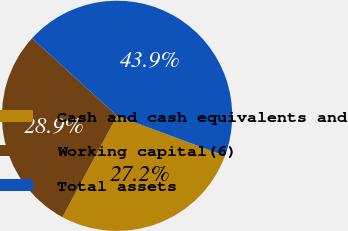Convert chart to OTSL. <chart><loc_0><loc_0><loc_500><loc_500><pie_chart><fcel>Cash and cash equivalents and<fcel>Working capital(6)<fcel>Total assets<nl><fcel>27.22%<fcel>28.89%<fcel>43.89%<nl></chart> 